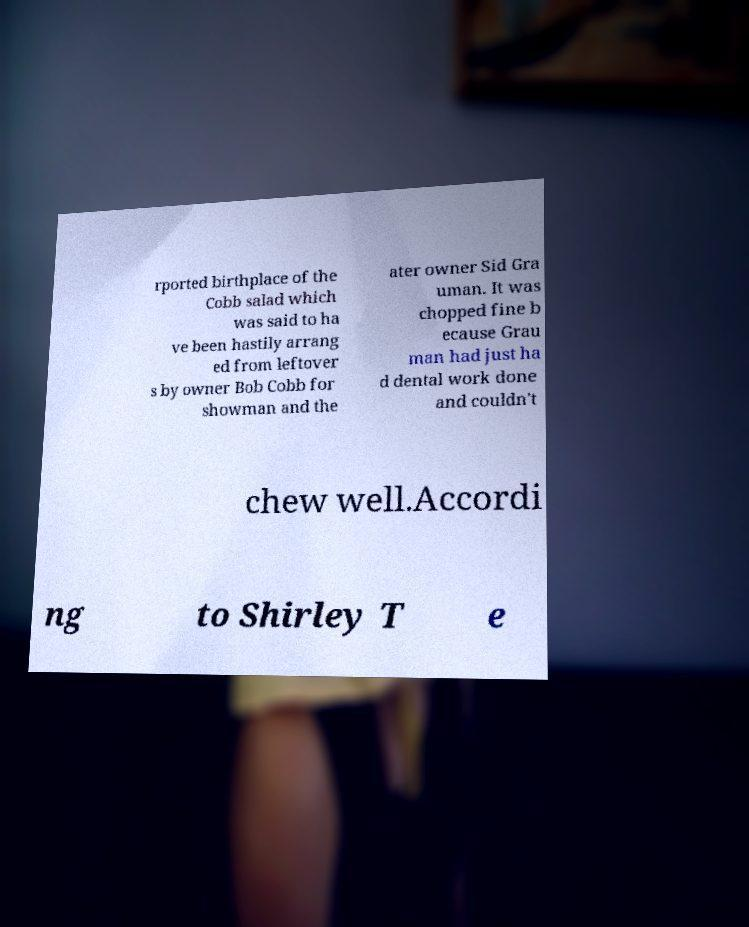For documentation purposes, I need the text within this image transcribed. Could you provide that? rported birthplace of the Cobb salad which was said to ha ve been hastily arrang ed from leftover s by owner Bob Cobb for showman and the ater owner Sid Gra uman. It was chopped fine b ecause Grau man had just ha d dental work done and couldn't chew well.Accordi ng to Shirley T e 